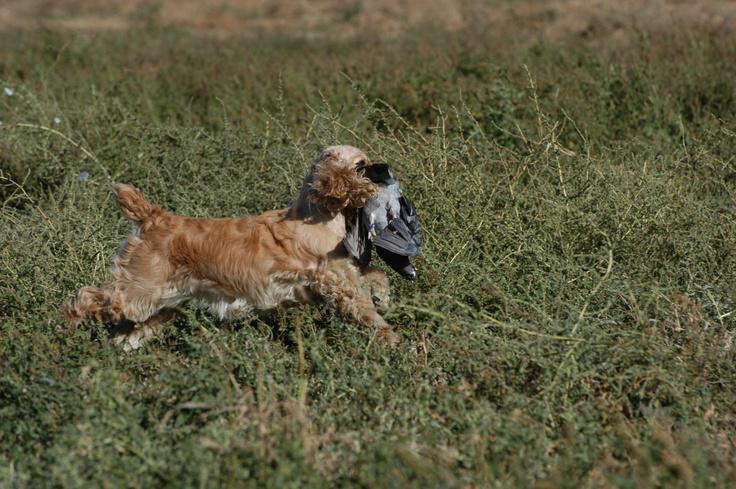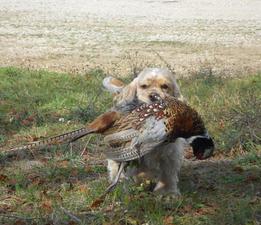The first image is the image on the left, the second image is the image on the right. For the images displayed, is the sentence "Each image shows a dog on dry land carrying a bird in its mouth." factually correct? Answer yes or no. Yes. The first image is the image on the left, the second image is the image on the right. Given the left and right images, does the statement "Each image shows a spaniel carrying a bird in its mouth across the ground." hold true? Answer yes or no. Yes. 